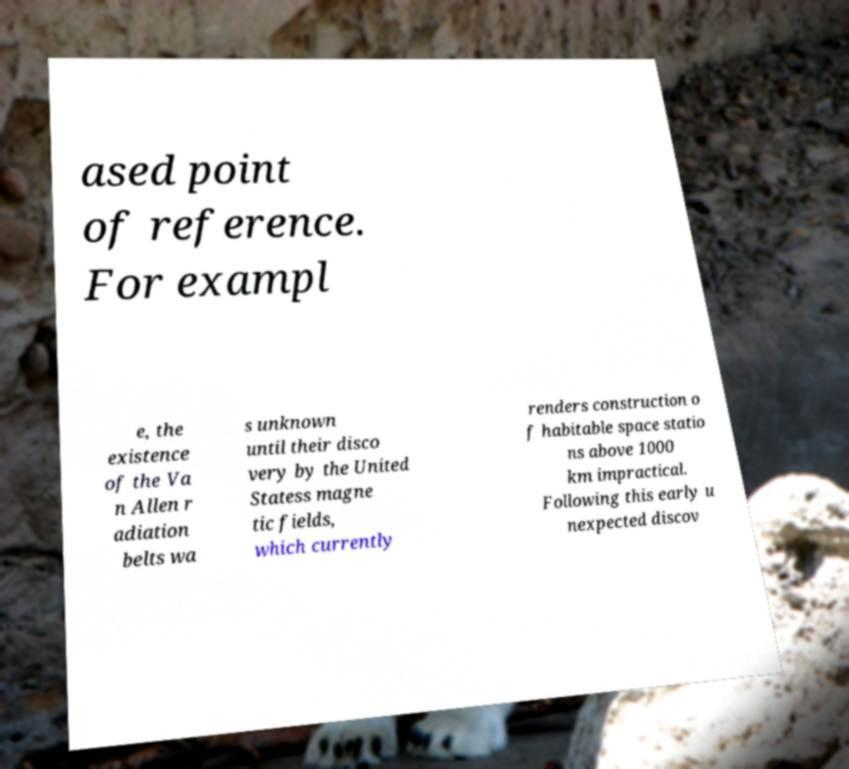There's text embedded in this image that I need extracted. Can you transcribe it verbatim? ased point of reference. For exampl e, the existence of the Va n Allen r adiation belts wa s unknown until their disco very by the United Statess magne tic fields, which currently renders construction o f habitable space statio ns above 1000 km impractical. Following this early u nexpected discov 